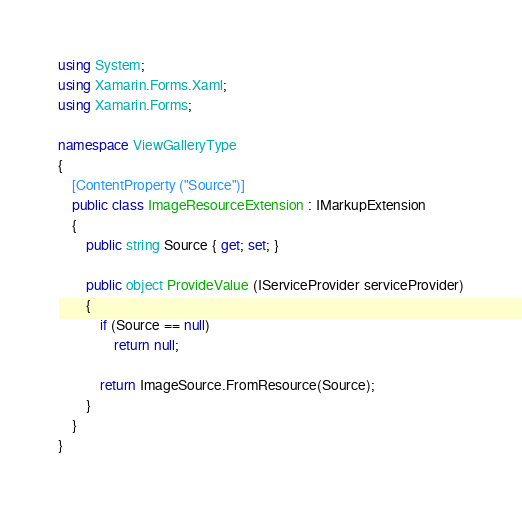<code> <loc_0><loc_0><loc_500><loc_500><_C#_>using System;
using Xamarin.Forms.Xaml;
using Xamarin.Forms;

namespace ViewGalleryType
{
    [ContentProperty ("Source")]
    public class ImageResourceExtension : IMarkupExtension
    {
        public string Source { get; set; }

        public object ProvideValue (IServiceProvider serviceProvider)
        {
            if (Source == null)
                return null;

            return ImageSource.FromResource(Source); 
        }
    }
}

</code> 